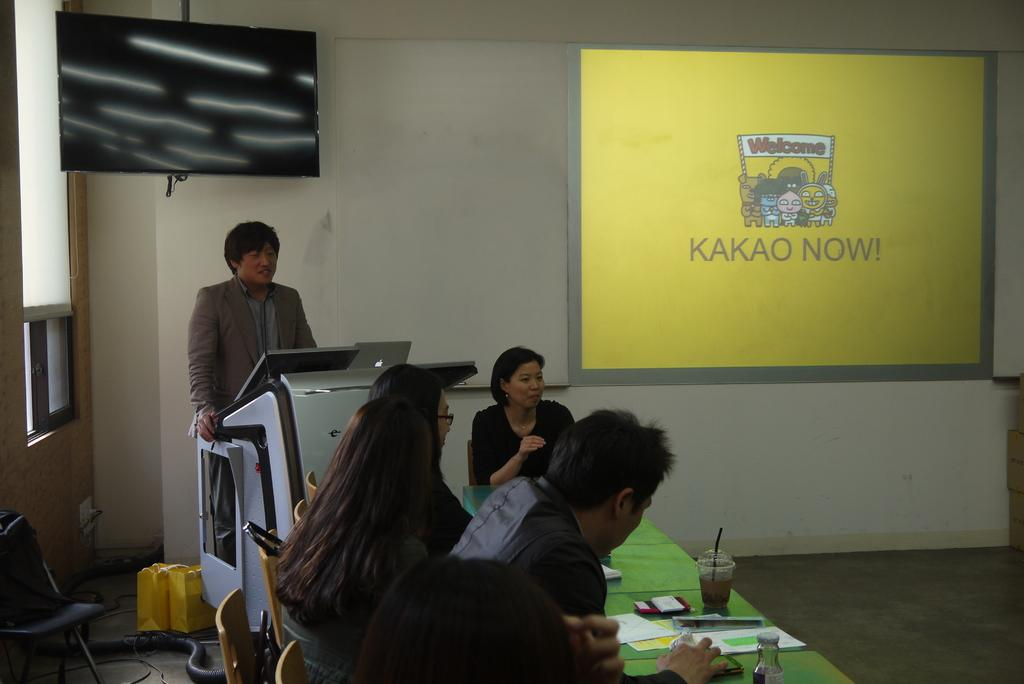<image>
Create a compact narrative representing the image presented. A screen shows a yellow display that says Kakao Now! 